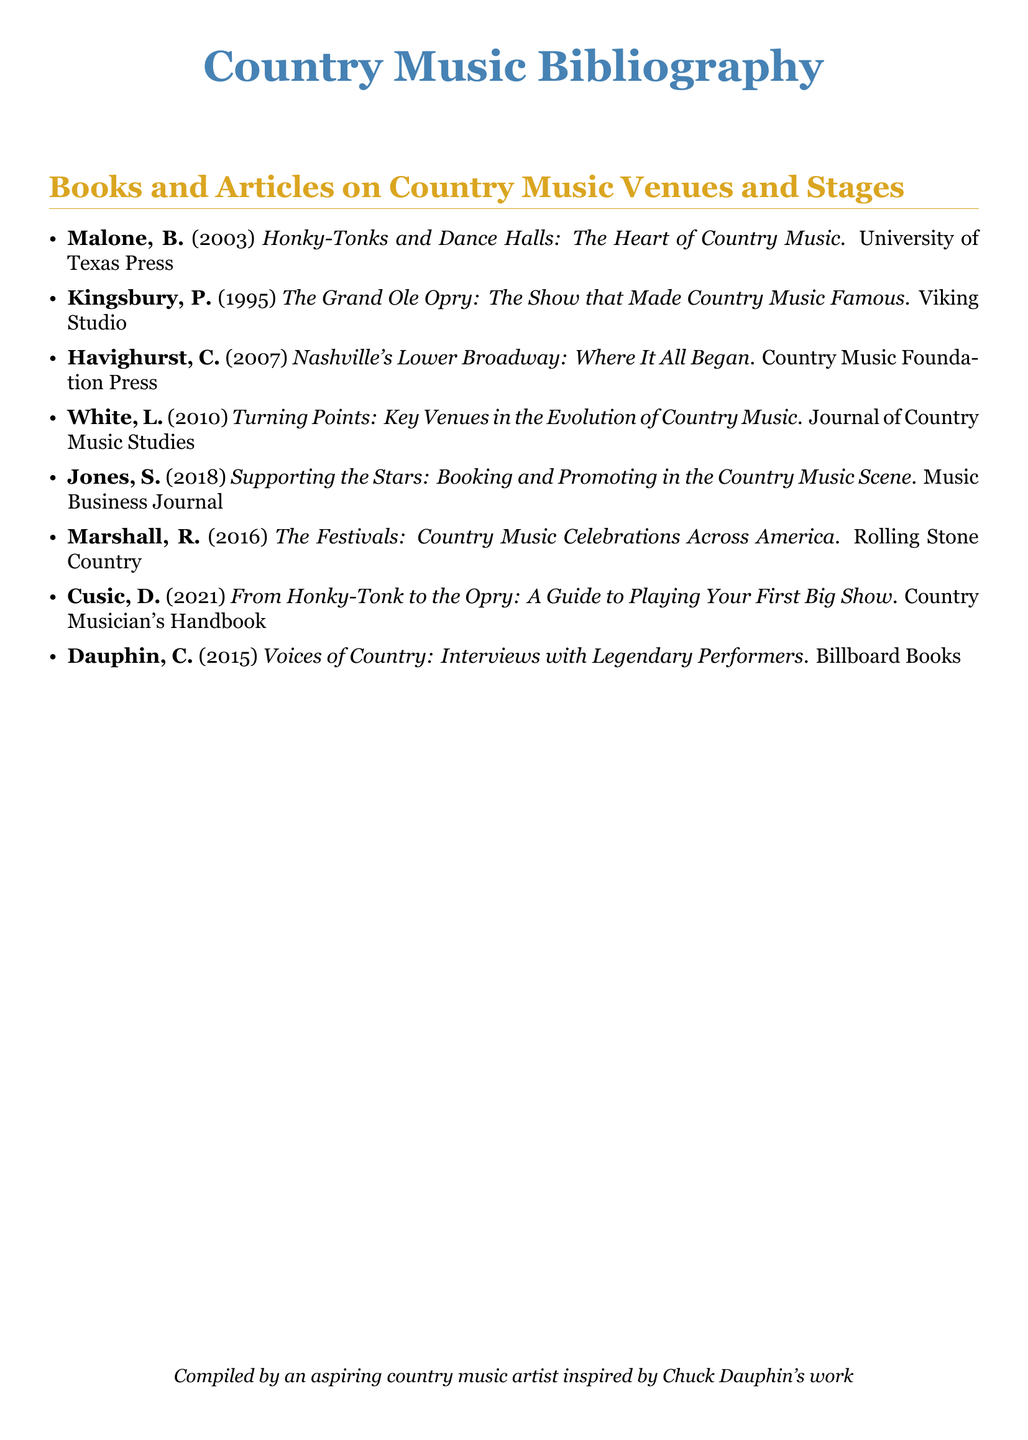What is the title of the first entry? The title of the first entry is the name of the book written by B. Malone, which is the first listed in the bibliography.
Answer: Honky-Tonks and Dance Halls: The Heart of Country Music Who is the author of the book published in 2010? The author of the book published in 2010, which focuses on key venues in the evolution of country music, is L. White.
Answer: L. White What year was "Supporting the Stars" published? The year "Supporting the Stars" by S. Jones was published is presented next to the author's name in the bibliography.
Answer: 2018 How many entries are listed in the bibliography? The total number of entries is counted from the list of books and articles provided in the document.
Answer: Eight What type of publication is "Voices of Country"? The type of publication for "Voices of Country" by C. Dauphin is a book, which is categorized among the other entries.
Answer: Book Which venue is specifically mentioned in the title of the book by P. Kingsbury? The venue mentioned in the title of the book by P. Kingsbury relates to a famous country music institution noted in the bibliography.
Answer: Grand Ole Opry What is the primary focus of Cusic's 2021 book? The primary focus of Cusic's 2021 book is indicated by its title, which suggests a guide for artists entering the country music scene.
Answer: Playing Your First Big Show What publication year corresponds with the entry by R. Marshall? The publication year for the entry by R. Marshall can be found next to the author's name in the list.
Answer: 2016 